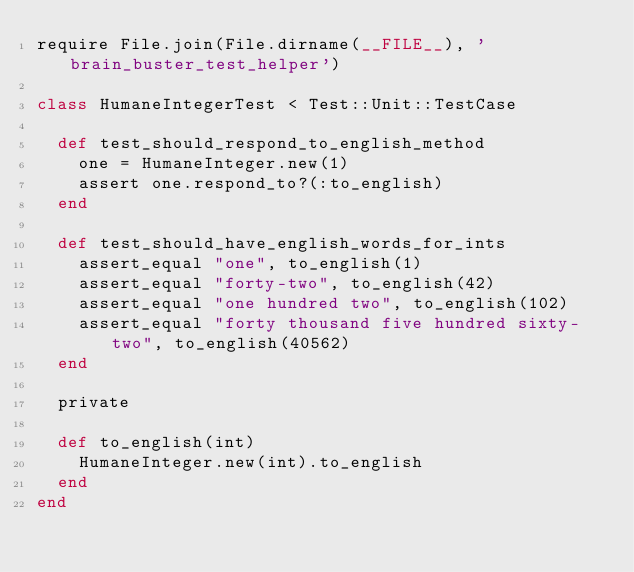<code> <loc_0><loc_0><loc_500><loc_500><_Ruby_>require File.join(File.dirname(__FILE__), 'brain_buster_test_helper')

class HumaneIntegerTest < Test::Unit::TestCase

  def test_should_respond_to_english_method
    one = HumaneInteger.new(1)
    assert one.respond_to?(:to_english)
  end
  
  def test_should_have_english_words_for_ints
    assert_equal "one", to_english(1)
    assert_equal "forty-two", to_english(42)
    assert_equal "one hundred two", to_english(102)
    assert_equal "forty thousand five hundred sixty-two", to_english(40562)
  end
  
  private
  
  def to_english(int)
    HumaneInteger.new(int).to_english
  end
end
</code> 